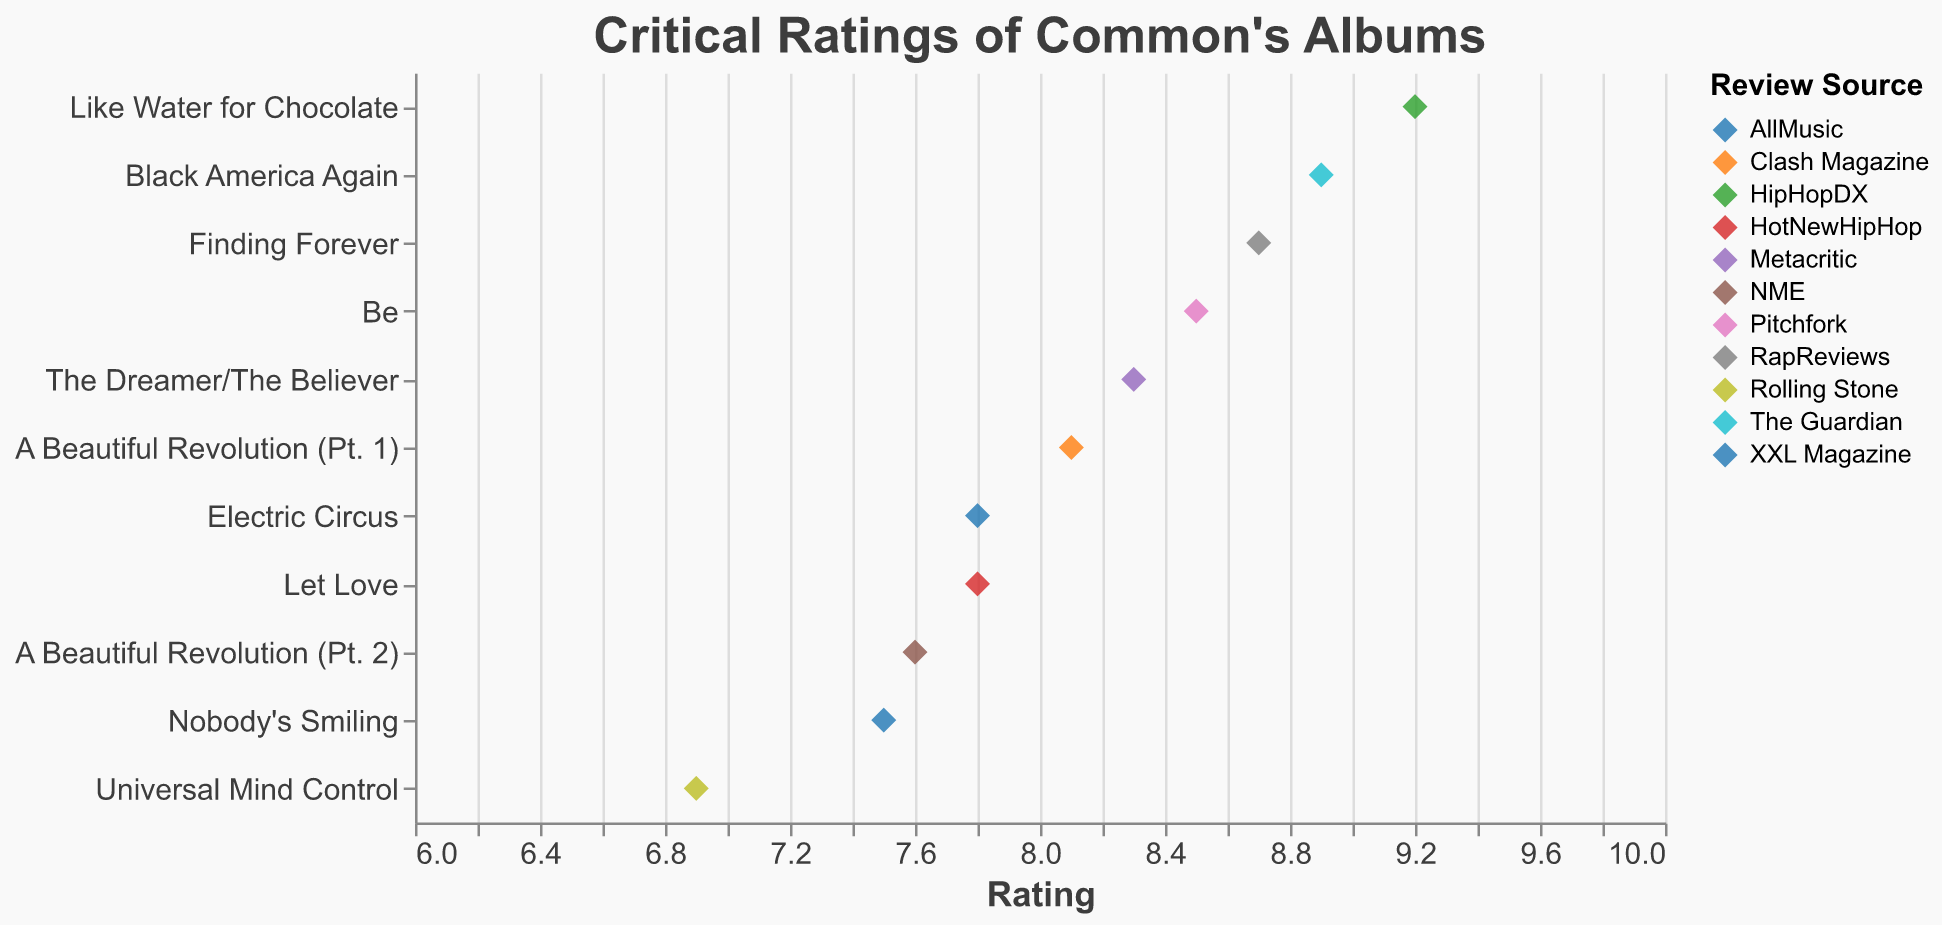How many data points are displayed in the figure? Count each unique entry of an album's rating from the data provided. There are 11 albums with ratings from different sources.
Answer: 11 Which album received the highest rating, and what was the rating? Identify the album with the highest numerical rating from the data. "Like Water for Chocolate" received the highest rating of 9.2.
Answer: Like Water for Chocolate, 9.2 What is the average rating for all the albums? Sum all the ratings and divide by the number of albums. The ratings are: 8.5, 9.2, 7.8, 8.7, 6.9, 8.3, 7.5, 8.9, 7.8, 8.1, 7.6. The sum is 89.3, and there are 11 albums, so the average is 89.3 / 11 ≈ 8.12.
Answer: 8.12 Which album received the lowest rating, and what was the rating? Identify the album with the lowest numerical rating from the data. "Universal Mind Control" received the lowest rating of 6.9.
Answer: Universal Mind Control, 6.9 How many albums have a rating above 8? Count the number of albums with a rating greater than 8. The albums are: "Be", "Like Water for Chocolate", "Finding Forever", "The Dreamer/The Believer", "Black America Again", "A Beautiful Revolution (Pt. 1)". There are 6 albums.
Answer: 6 What is the difference in rating between "Be" and "Let Love"? Subtract the rating of “Let Love” from the rating of “Be”. The rating for “Be” is 8.5, and for “Let Love” it is 7.8. The difference is 8.5 - 7.8 = 0.7.
Answer: 0.7 Which album reviewed by Metacritic, and what was its rating? Look for the source "Metacritic" from the data and identify the respective album and its rating. The album is "The Dreamer/The Believer" with a rating of 8.3.
Answer: The Dreamer/The Believer, 8.3 Compare the ratings of "Finding Forever" and "A Beautiful Revolution (Pt. 2)". Which one received a higher rating, and by how much? Subtract the rating of “A Beautiful Revolution (Pt. 2)” from the rating of “Finding Forever”. "Finding Forever" has a rating of 8.7, and "A Beautiful Revolution (Pt. 2)" has a rating of 7.6. The difference is 8.7 - 7.6 = 1.1, and "Finding Forever" has a higher rating.
Answer: Finding Forever, 1.1 Which albums have the same rating, and what is that rating? Identify any albums with identical numerical ratings in the dataset. "Electric Circus" and "Let Love" both have a rating of 7.8.
Answer: Electric Circus and Let Love, 7.8 What is the median rating of the albums? To find the median, list all ratings in numerical order and identify the middle value. The ordered ratings are: 6.9, 7.5, 7.6, 7.8, 7.8, 8.1, 8.3, 8.5, 8.7, 8.9, 9.2. The median rating, being the 6th value in an ordered list of 11, is 8.1.
Answer: 8.1 